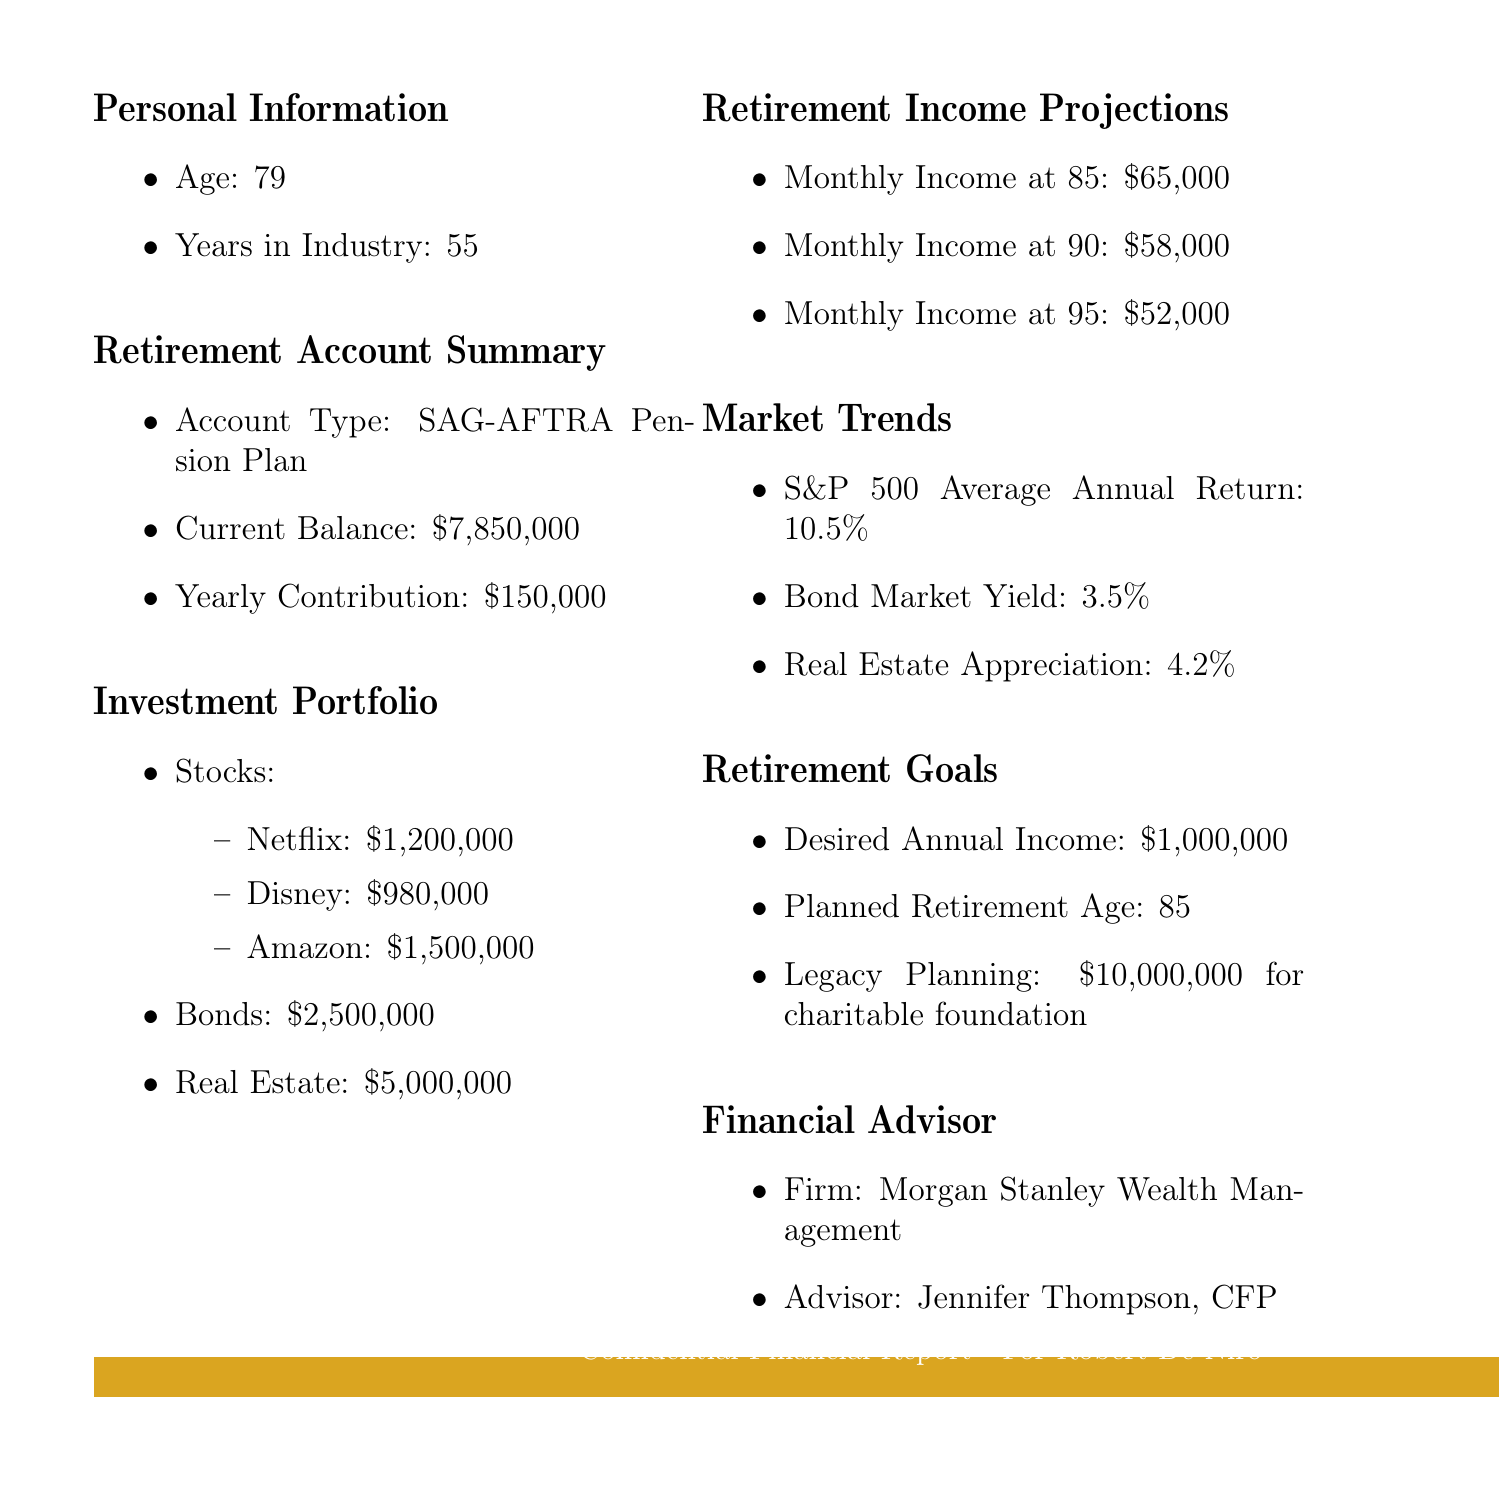What is the current balance of the retirement account? The current balance is stated in the retirement account summary under the current balance section, which is $7,850,000.
Answer: $7,850,000 Who is the financial advisor? The advisor's name is listed in the financial advisor section, which states Jennifer Thompson, CFP as the advisor.
Answer: Jennifer Thompson, CFP What is the yearly contribution to the retirement account? The yearly contribution is found in the retirement account summary, which indicates it is $150,000.
Answer: $150,000 What are the stocks included in the investment portfolio? The stocks are listed under the investment portfolio section, which includes Netflix, Disney, and Amazon.
Answer: Netflix, Disney, Amazon What is the desired annual income at retirement? The desired annual income is mentioned in the retirement goals section and it states $1,000,000.
Answer: $1,000,000 How much does the monthly income decrease from age 85 to 90? The monthly income at 85 is compared to the monthly income at 90 to find the difference, which is $65,000 - $58,000 = $7,000.
Answer: $7,000 What is the average annual return of the S&P 500? The average annual return for the S&P 500 is detailed under market trends, indicating it is 10.5%.
Answer: 10.5% What is the planned retirement age? The planned retirement age is explicitly mentioned in the retirement goals section, stating it is 85.
Answer: 85 What is the total amount allocated to real estate? The total amount allocated to real estate is noted in the investment portfolio section, which states $5,000,000.
Answer: $5,000,000 What is the legacy planning amount for the charitable foundation? The legacy planning amount is listed in the retirement goals section, specifying $10,000,000 for the charitable foundation.
Answer: $10,000,000 